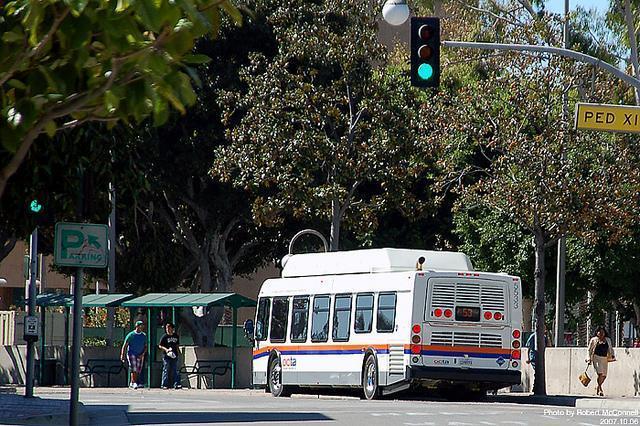How many chairs are facing the far wall?
Give a very brief answer. 0. 